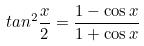Convert formula to latex. <formula><loc_0><loc_0><loc_500><loc_500>t a n ^ { 2 } \frac { x } { 2 } = \frac { 1 - \cos x } { 1 + \cos x }</formula> 